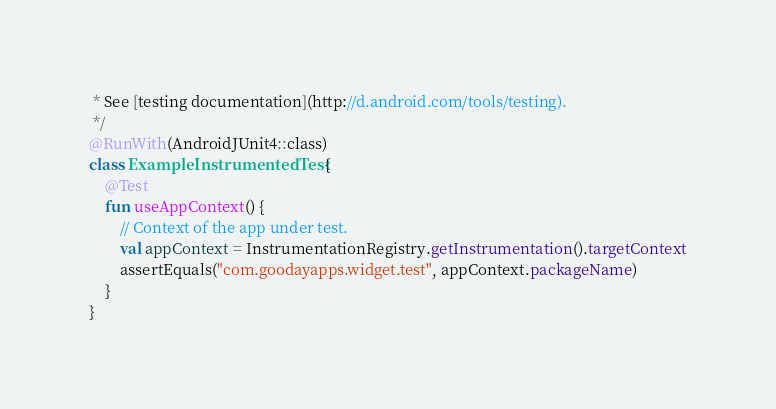Convert code to text. <code><loc_0><loc_0><loc_500><loc_500><_Kotlin_> * See [testing documentation](http://d.android.com/tools/testing).
 */
@RunWith(AndroidJUnit4::class)
class ExampleInstrumentedTest {
    @Test
    fun useAppContext() {
        // Context of the app under test.
        val appContext = InstrumentationRegistry.getInstrumentation().targetContext
        assertEquals("com.goodayapps.widget.test", appContext.packageName)
    }
}</code> 